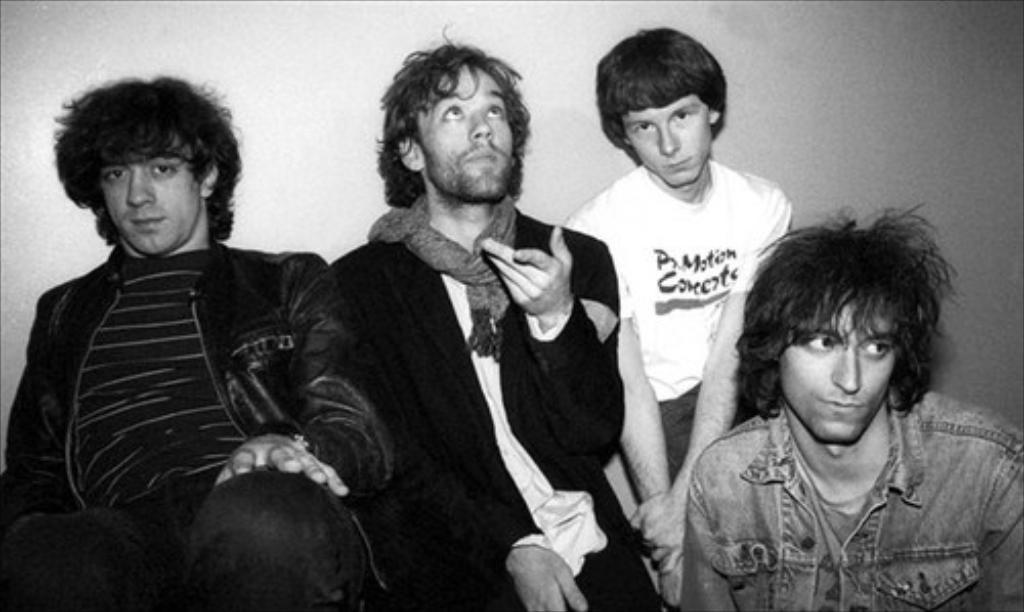What is the color scheme of the image? The image is black and white. What can be seen in the image? There are people in the image. What is visible in the background of the image? There is a wall in the background of the image. How many kittens are learning to play the piano in the image? There are no kittens or pianos present in the image; it features people and a wall in a black and white color scheme. 